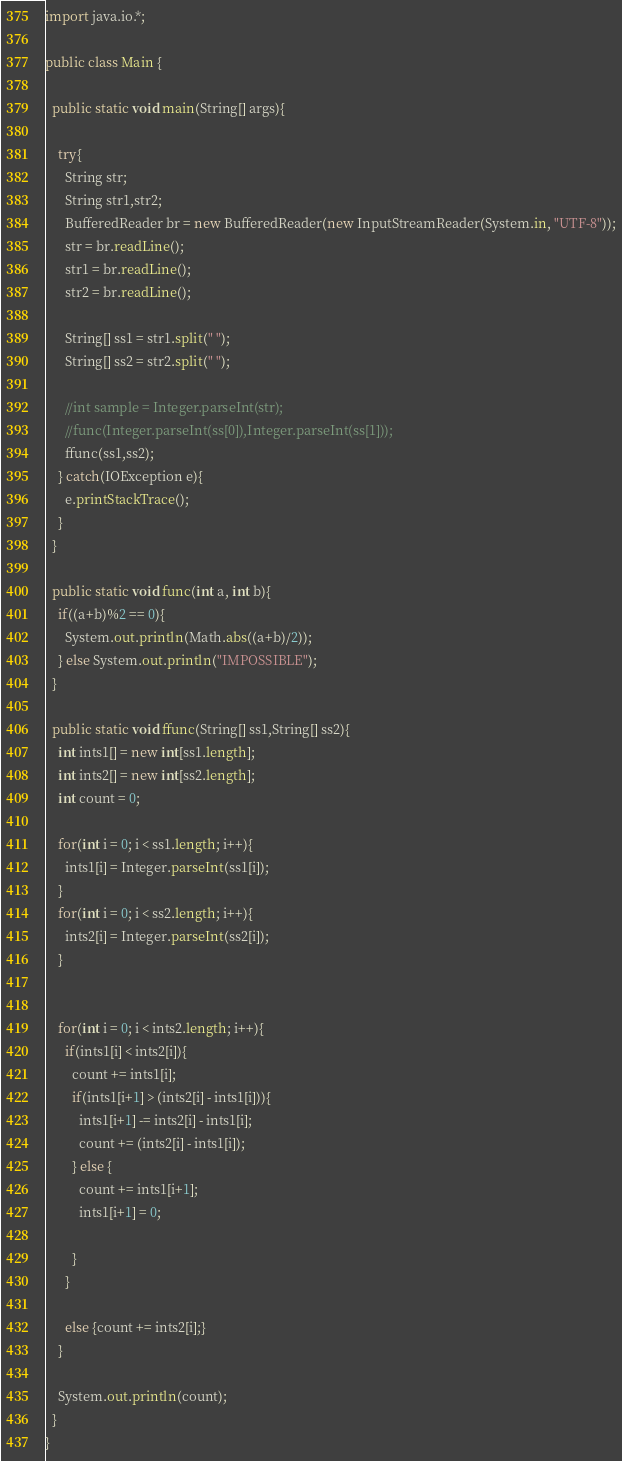<code> <loc_0><loc_0><loc_500><loc_500><_Java_>import java.io.*;

public class Main {

  public static void main(String[] args){

    try{
      String str;
      String str1,str2;
      BufferedReader br = new BufferedReader(new InputStreamReader(System.in, "UTF-8"));
      str = br.readLine();
      str1 = br.readLine();
      str2 = br.readLine();

      String[] ss1 = str1.split(" ");
      String[] ss2 = str2.split(" ");

      //int sample = Integer.parseInt(str);
      //func(Integer.parseInt(ss[0]),Integer.parseInt(ss[1]));
      ffunc(ss1,ss2);
    } catch(IOException e){
      e.printStackTrace();
    }
  }

  public static void func(int a, int b){
    if((a+b)%2 == 0){
      System.out.println(Math.abs((a+b)/2));
    } else System.out.println("IMPOSSIBLE");
  }

  public static void ffunc(String[] ss1,String[] ss2){
    int ints1[] = new int[ss1.length];
    int ints2[] = new int[ss2.length];
    int count = 0;

    for(int i = 0; i < ss1.length; i++){
      ints1[i] = Integer.parseInt(ss1[i]);
    }
    for(int i = 0; i < ss2.length; i++){
      ints2[i] = Integer.parseInt(ss2[i]);
    }


    for(int i = 0; i < ints2.length; i++){
      if(ints1[i] < ints2[i]){
        count += ints1[i];
        if(ints1[i+1] > (ints2[i] - ints1[i])){
          ints1[i+1] -= ints2[i] - ints1[i];
          count += (ints2[i] - ints1[i]);
        } else {
          count += ints1[i+1];
          ints1[i+1] = 0;

        }
      }

      else {count += ints2[i];}
    }

    System.out.println(count);
  }
}
</code> 